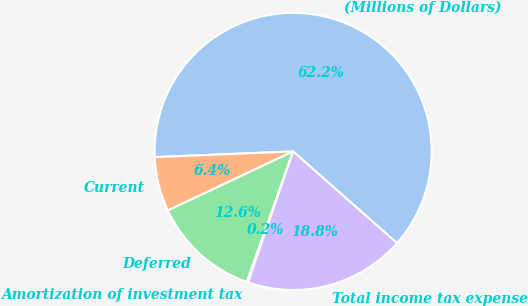Convert chart. <chart><loc_0><loc_0><loc_500><loc_500><pie_chart><fcel>(Millions of Dollars)<fcel>Current<fcel>Deferred<fcel>Amortization of investment tax<fcel>Total income tax expense<nl><fcel>62.17%<fcel>6.36%<fcel>12.56%<fcel>0.15%<fcel>18.76%<nl></chart> 